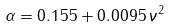<formula> <loc_0><loc_0><loc_500><loc_500>\alpha = 0 . 1 5 5 + 0 . 0 0 9 5 \, \nu ^ { 2 }</formula> 